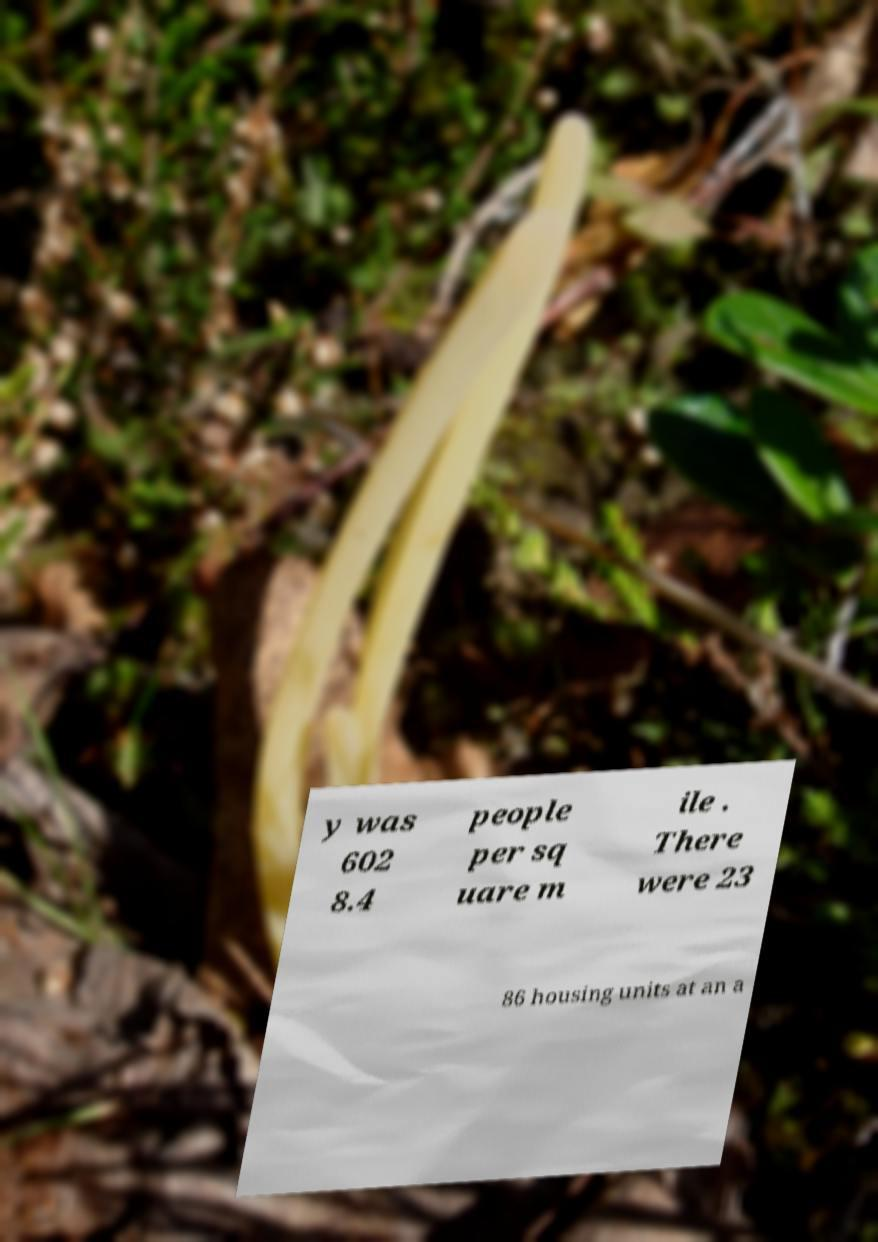I need the written content from this picture converted into text. Can you do that? y was 602 8.4 people per sq uare m ile . There were 23 86 housing units at an a 